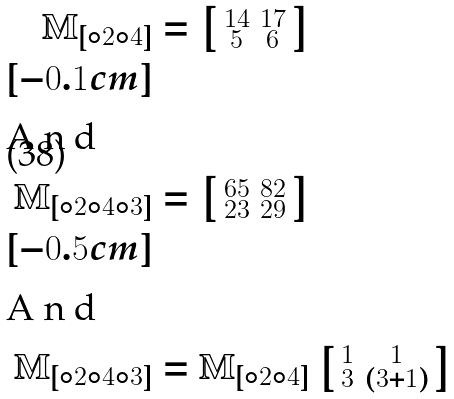Convert formula to latex. <formula><loc_0><loc_0><loc_500><loc_500>\mathbb { M } _ { [ \circ 2 \circ 4 ] } & = \left [ \begin{smallmatrix} 1 4 & 1 7 \\ 5 & 6 \end{smallmatrix} \right ] \\ [ - 0 . 1 c m ] \intertext { A n d } \mathbb { M } _ { [ \circ 2 \circ 4 \circ 3 ] } & = \left [ \begin{smallmatrix} 6 5 & 8 2 \\ 2 3 & 2 9 \end{smallmatrix} \right ] \\ [ - 0 . 5 c m ] \intertext { A n d } \mathbb { M } _ { [ \circ 2 \circ 4 \circ 3 ] } & = \mathbb { M } _ { [ \circ 2 \circ 4 ] } \left [ \begin{smallmatrix} 1 & 1 \\ 3 & ( 3 + 1 ) \end{smallmatrix} \right ]</formula> 